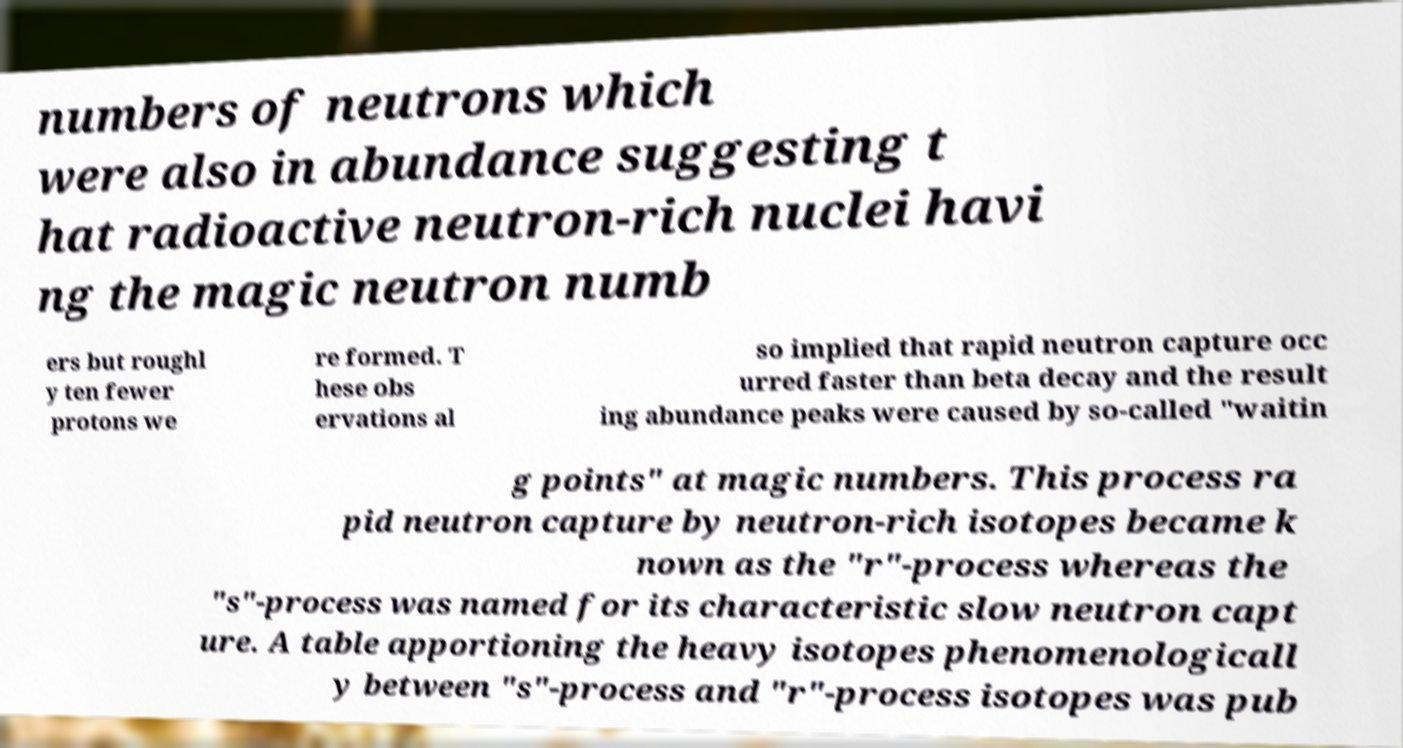Can you read and provide the text displayed in the image?This photo seems to have some interesting text. Can you extract and type it out for me? numbers of neutrons which were also in abundance suggesting t hat radioactive neutron-rich nuclei havi ng the magic neutron numb ers but roughl y ten fewer protons we re formed. T hese obs ervations al so implied that rapid neutron capture occ urred faster than beta decay and the result ing abundance peaks were caused by so-called "waitin g points" at magic numbers. This process ra pid neutron capture by neutron-rich isotopes became k nown as the "r"-process whereas the "s"-process was named for its characteristic slow neutron capt ure. A table apportioning the heavy isotopes phenomenologicall y between "s"-process and "r"-process isotopes was pub 